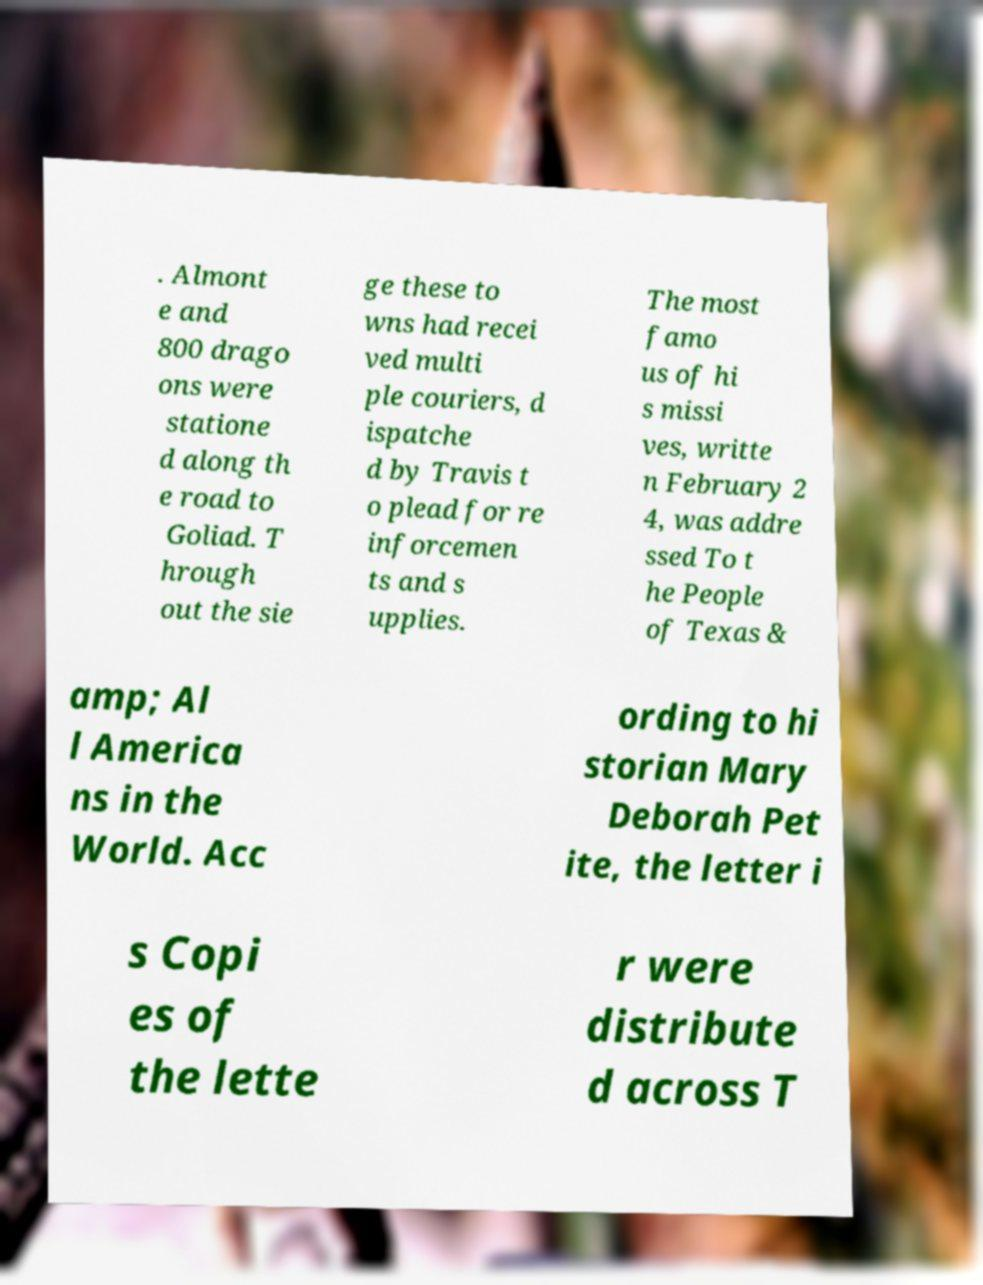There's text embedded in this image that I need extracted. Can you transcribe it verbatim? . Almont e and 800 drago ons were statione d along th e road to Goliad. T hrough out the sie ge these to wns had recei ved multi ple couriers, d ispatche d by Travis t o plead for re inforcemen ts and s upplies. The most famo us of hi s missi ves, writte n February 2 4, was addre ssed To t he People of Texas & amp; Al l America ns in the World. Acc ording to hi storian Mary Deborah Pet ite, the letter i s Copi es of the lette r were distribute d across T 